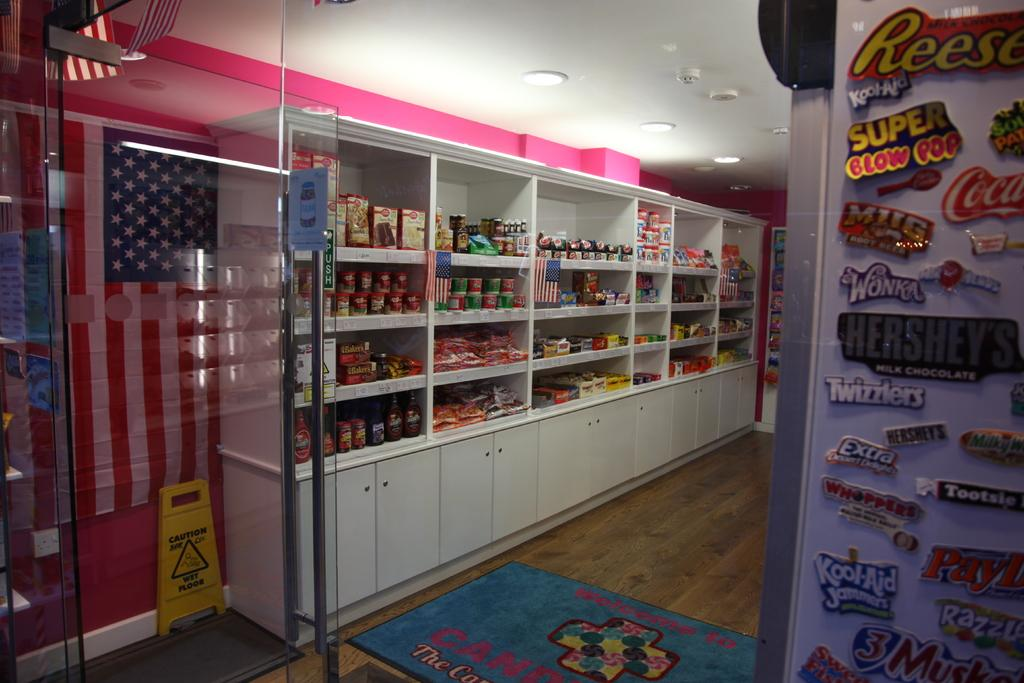<image>
Provide a brief description of the given image. the inside of a candy store with magnets for recees and twizzlers and other brands 